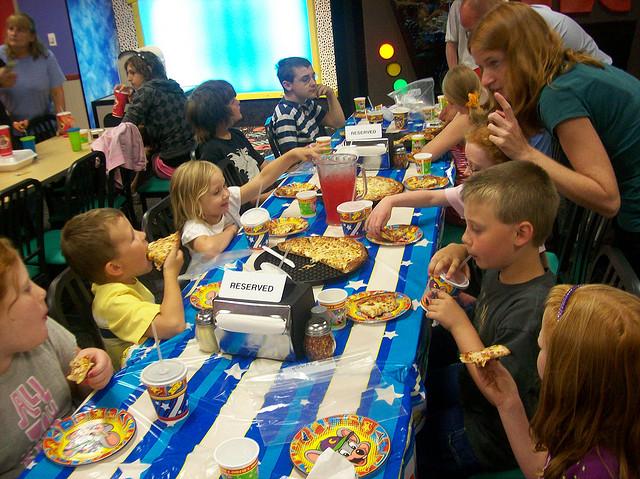What are the students drinking?
Concise answer only. Juice. What type of celebration is this?
Concise answer only. Birthday. Who are they?
Be succinct. Children. Where are the kids?
Be succinct. At table. What snake are the children eating?
Keep it brief. Pizza. What does the note on the napkin holder say?
Concise answer only. Reserved. 